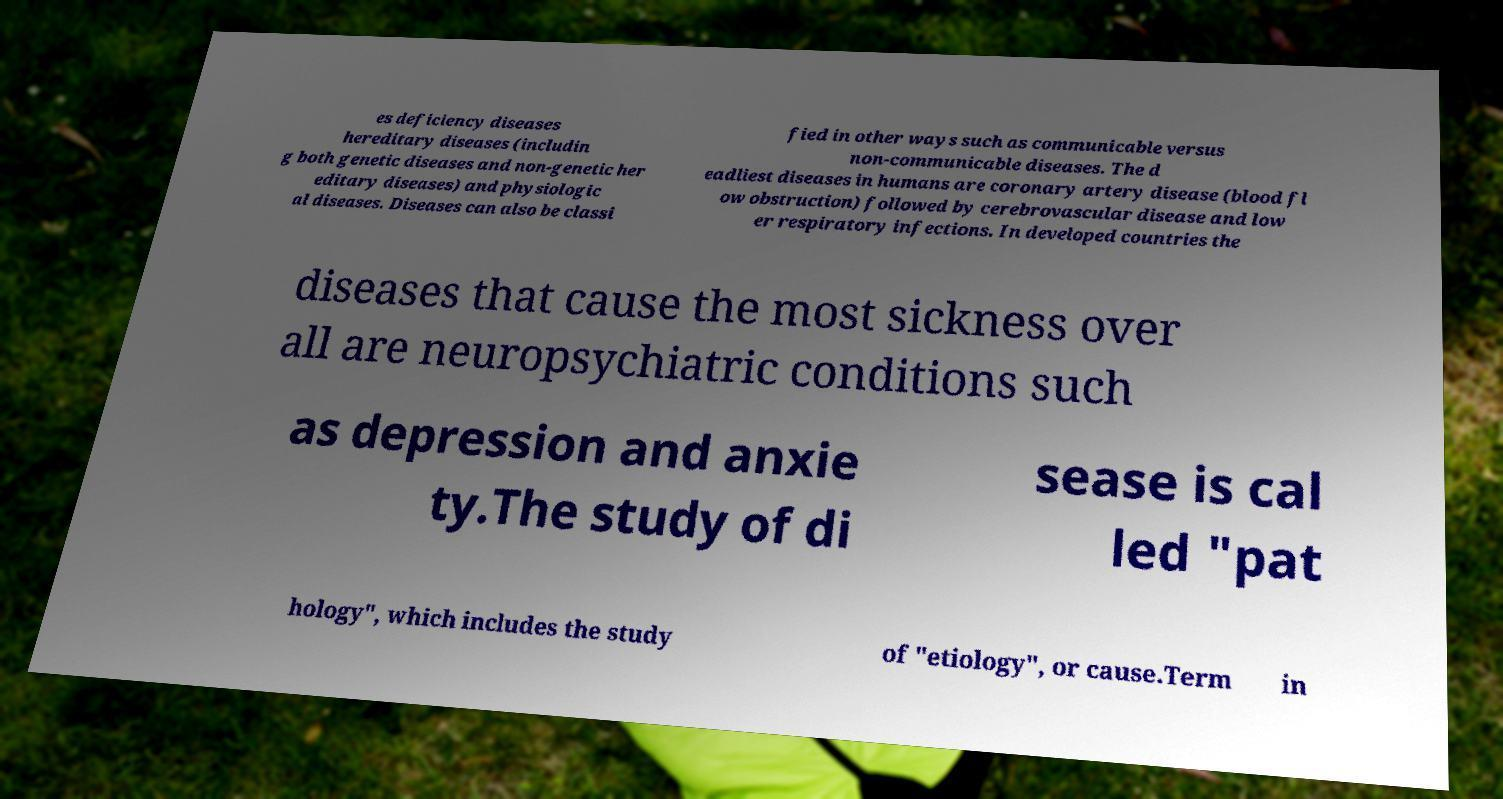Please identify and transcribe the text found in this image. es deficiency diseases hereditary diseases (includin g both genetic diseases and non-genetic her editary diseases) and physiologic al diseases. Diseases can also be classi fied in other ways such as communicable versus non-communicable diseases. The d eadliest diseases in humans are coronary artery disease (blood fl ow obstruction) followed by cerebrovascular disease and low er respiratory infections. In developed countries the diseases that cause the most sickness over all are neuropsychiatric conditions such as depression and anxie ty.The study of di sease is cal led "pat hology", which includes the study of "etiology", or cause.Term in 